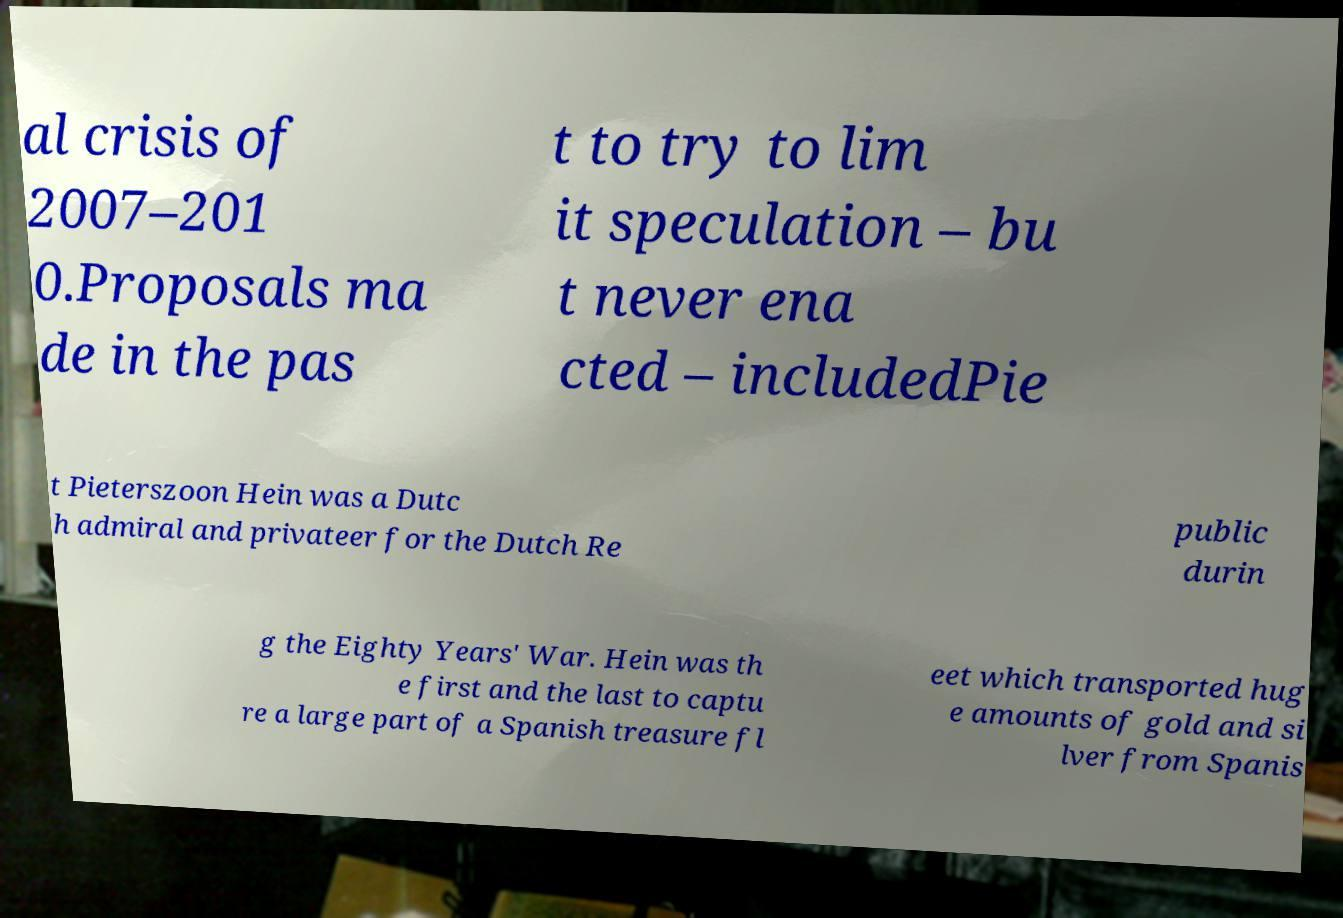Could you extract and type out the text from this image? al crisis of 2007–201 0.Proposals ma de in the pas t to try to lim it speculation – bu t never ena cted – includedPie t Pieterszoon Hein was a Dutc h admiral and privateer for the Dutch Re public durin g the Eighty Years' War. Hein was th e first and the last to captu re a large part of a Spanish treasure fl eet which transported hug e amounts of gold and si lver from Spanis 